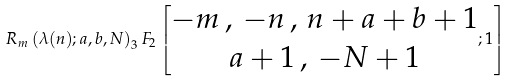Convert formula to latex. <formula><loc_0><loc_0><loc_500><loc_500>R _ { m } \left ( \lambda ( n ) ; a , b , N \right ) _ { 3 } F _ { 2 } \left [ \begin{matrix} - m \, , \, - n \, , \, n + a + b + 1 \\ a + 1 \, , \, - N + 1 \end{matrix} ; 1 \right ]</formula> 